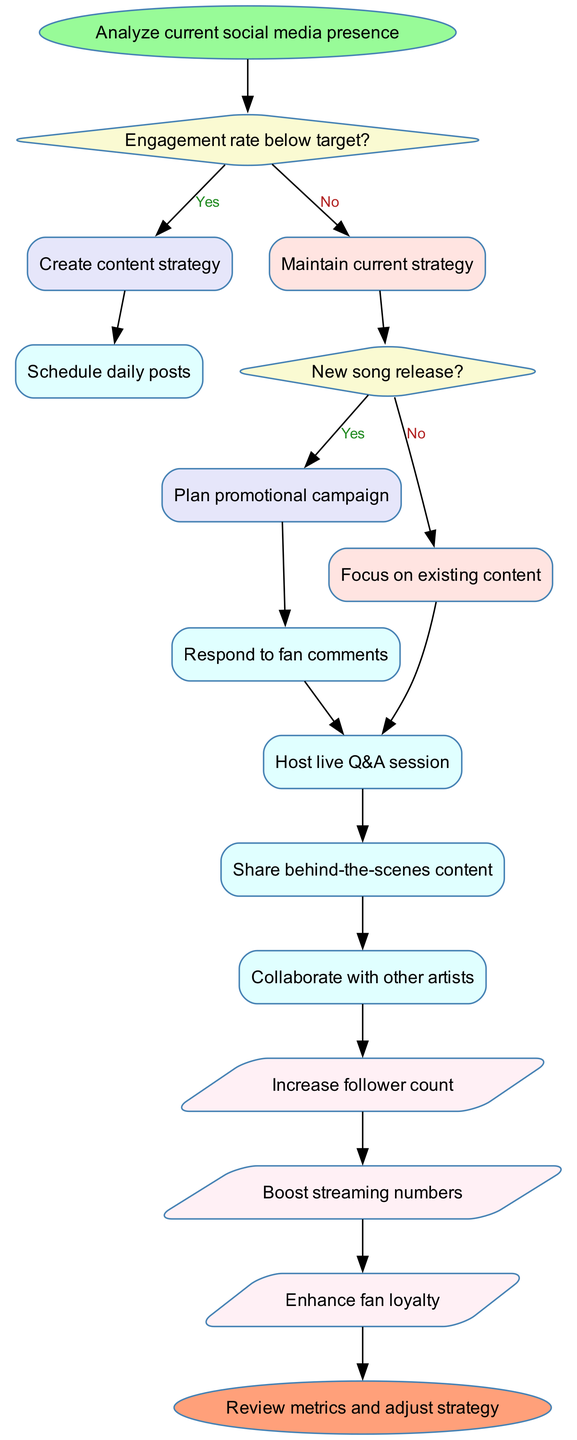What's the starting point of the flowchart? The starting point is labeled as "Analyze current social media presence," which is the first action node in the flowchart.
Answer: Analyze current social media presence What decision follows the first step? After "Analyze current social media presence," the first decision node checks if the engagement rate is below the target.
Answer: Engagement rate below target? How many processes are defined in the flowchart? The flowchart contains five process nodes that detail specific actions to take.
Answer: Five What happens if the engagement rate is below target? If the engagement rate is below target, the flowchart directs to the action "Create content strategy" as the next step.
Answer: Create content strategy What is the final output listed in the flowchart? The final output before reaching the end node is "Enhance fan loyalty," which is the last output in the series.
Answer: Enhance fan loyalty What is the last decision point in the flowchart? The last decision point checks if a new song is being released, determining the next steps based on that condition.
Answer: New song release? What process follows the decision where a new song is released? If there is a new song release, the flowchart proceeds to "Plan promotional campaign," which is an action taken based on this decision.
Answer: Plan promotional campaign How many outputs are mentioned in the diagram? There are three outputs listed in the flowchart: "Increase follower count," "Boost streaming numbers," and "Enhance fan loyalty."
Answer: Three What is the connection between the last output and the end of the flowchart? The last output "Enhance fan loyalty" directly connects to the end node, indicating that all processes lead towards reviewing metrics and adjusting strategy.
Answer: Review metrics and adjust strategy 